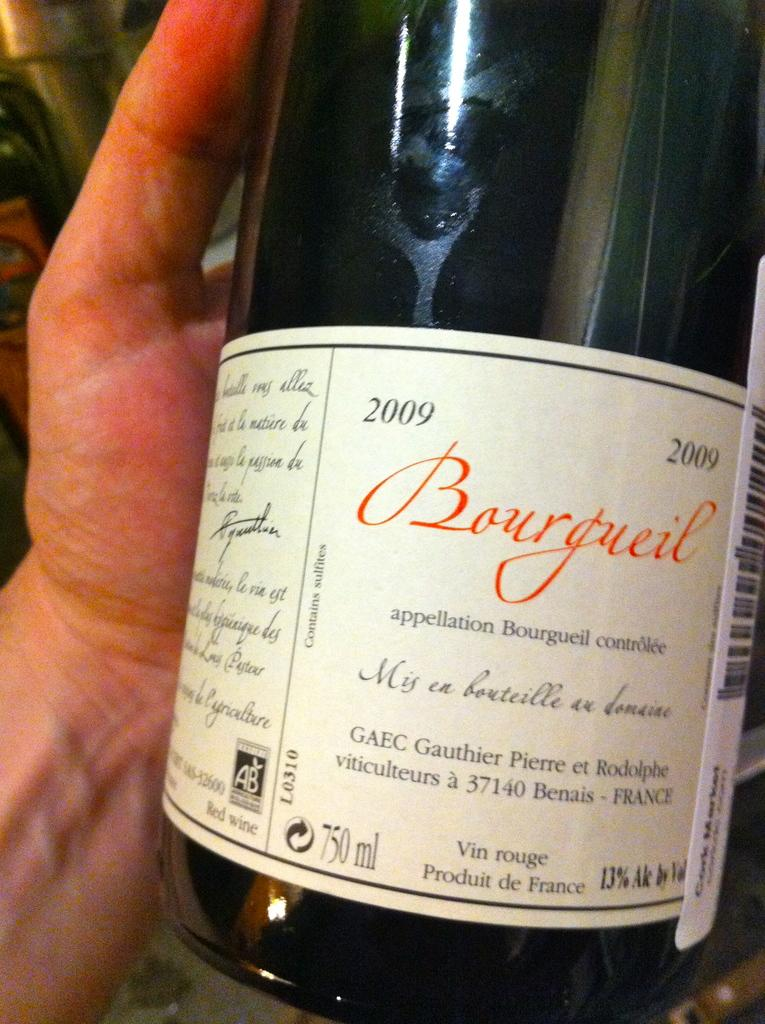Provide a one-sentence caption for the provided image. A 2009 bottle of Bourgueil with 13% Alcohol by Volume. 